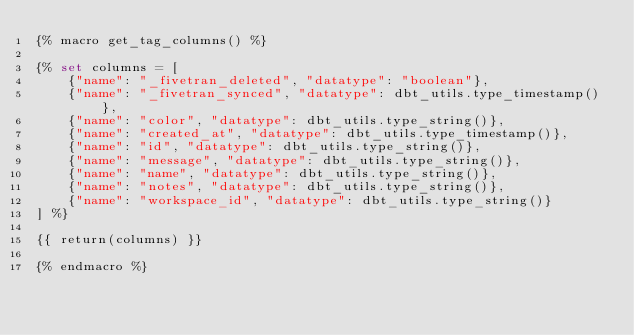<code> <loc_0><loc_0><loc_500><loc_500><_SQL_>{% macro get_tag_columns() %}

{% set columns = [
    {"name": "_fivetran_deleted", "datatype": "boolean"},
    {"name": "_fivetran_synced", "datatype": dbt_utils.type_timestamp()},
    {"name": "color", "datatype": dbt_utils.type_string()},
    {"name": "created_at", "datatype": dbt_utils.type_timestamp()},
    {"name": "id", "datatype": dbt_utils.type_string()},
    {"name": "message", "datatype": dbt_utils.type_string()},
    {"name": "name", "datatype": dbt_utils.type_string()},
    {"name": "notes", "datatype": dbt_utils.type_string()},
    {"name": "workspace_id", "datatype": dbt_utils.type_string()}
] %}

{{ return(columns) }}

{% endmacro %}
</code> 